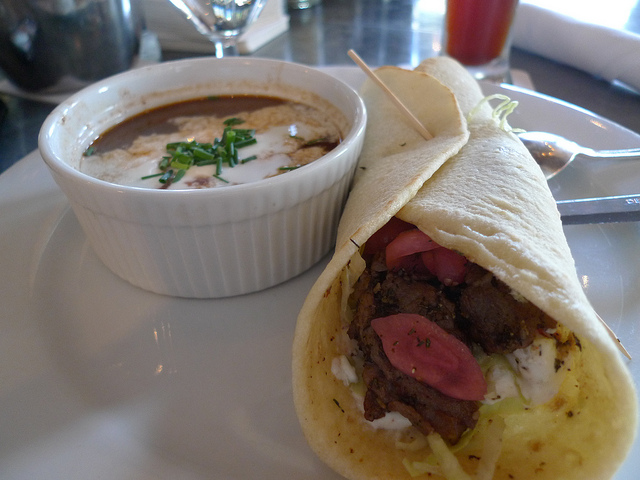<image>What is the sandwich wrapped in? I am not sure what the sandwich is wrapped in. It could be either bread or tortilla. What is the sandwich wrapped in? I am not sure what the sandwich is wrapped in. It can be bread or tortilla. 